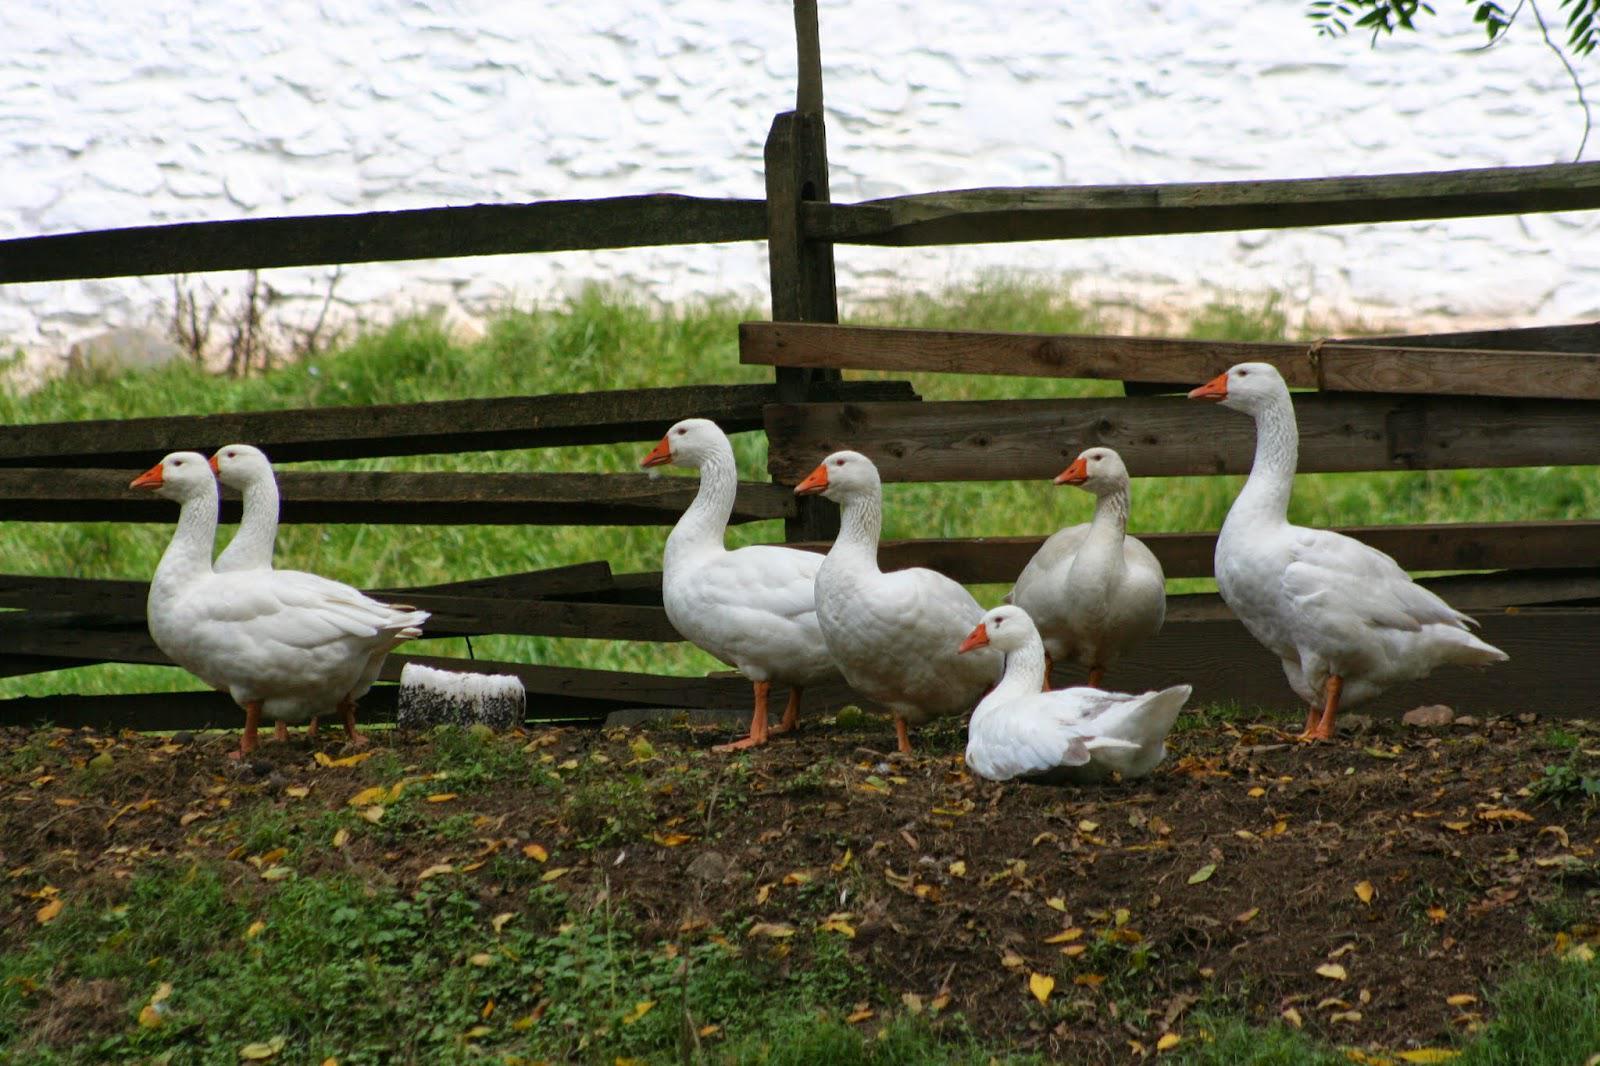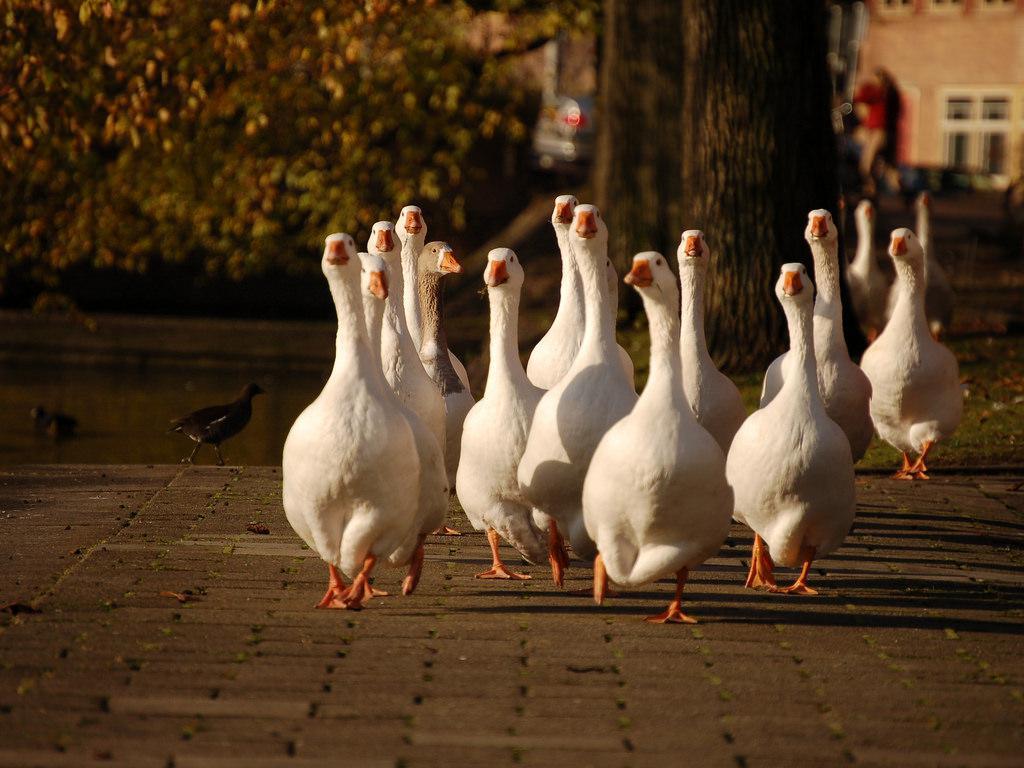The first image is the image on the left, the second image is the image on the right. Analyze the images presented: Is the assertion "The right image shows birds standing in grass." valid? Answer yes or no. No. The first image is the image on the left, the second image is the image on the right. Assess this claim about the two images: "An image shows a group of water fowl all walking in the same direction.". Correct or not? Answer yes or no. Yes. 